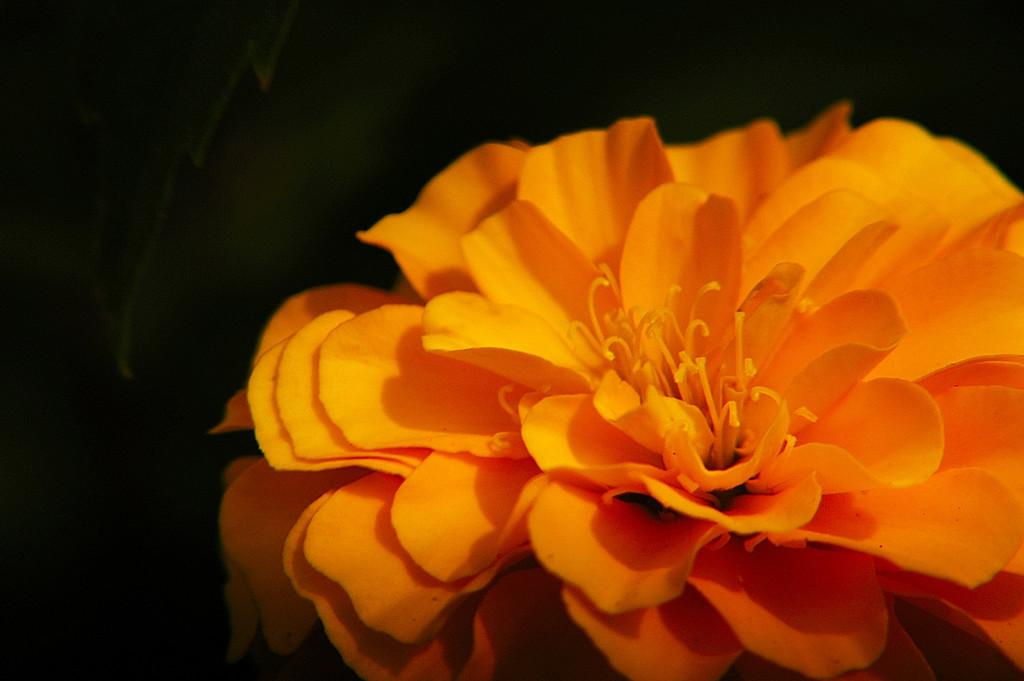What is present in the image? There is a flower in the image. What is the color of the flower? The flower is orange in color. What can be observed about the background of the image? The background of the image is dark. Where is the station located in the image? There is no station present in the image. What type of books can be seen on the flower's petals in the image? There are no books present in the image, and the flower's petals are not large enough to hold books. 